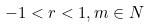Convert formula to latex. <formula><loc_0><loc_0><loc_500><loc_500>- 1 < r < 1 , m \in N</formula> 